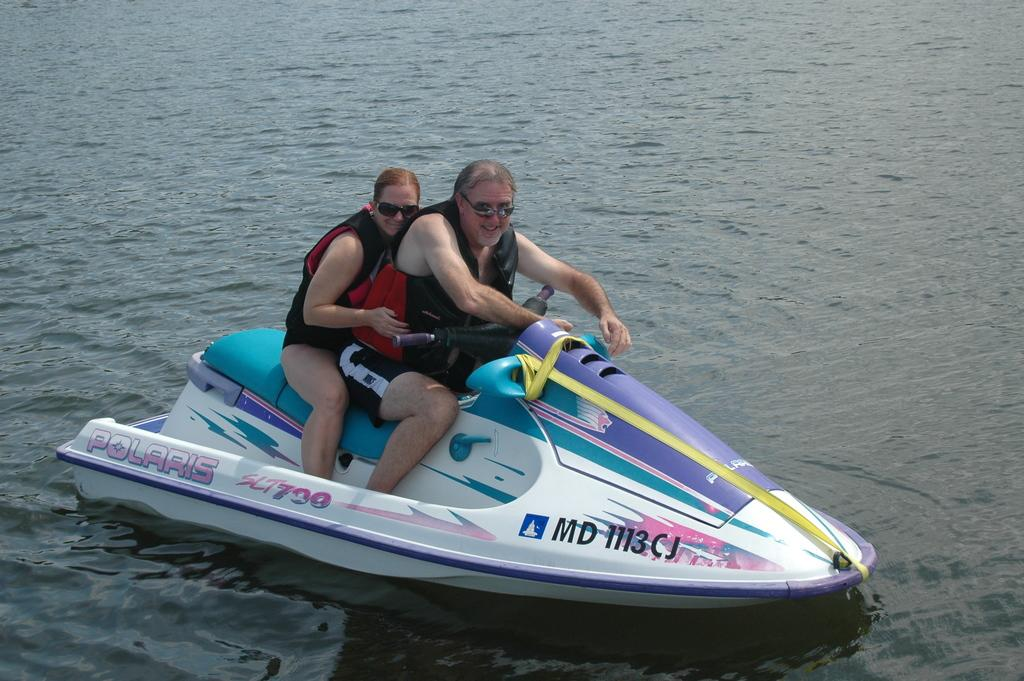What is the main object in the image? There is a jet ski in the image. Who is on the jet ski? Two people are on the jet ski. What safety precautions are the people taking? The people are wearing life jackets. jackets. What else can be seen on the people? The people are wearing spectacles. How are the people feeling in the image? The people are smiling. What is the environment like in the image? There is water visible in the image. Can you see any rifles or bags on the jet ski in the image? No, there are no rifles or bags visible on the jet ski in the image. Are there any trees present in the image? No, there are no trees visible in the image; it appears to be a water-based environment. 